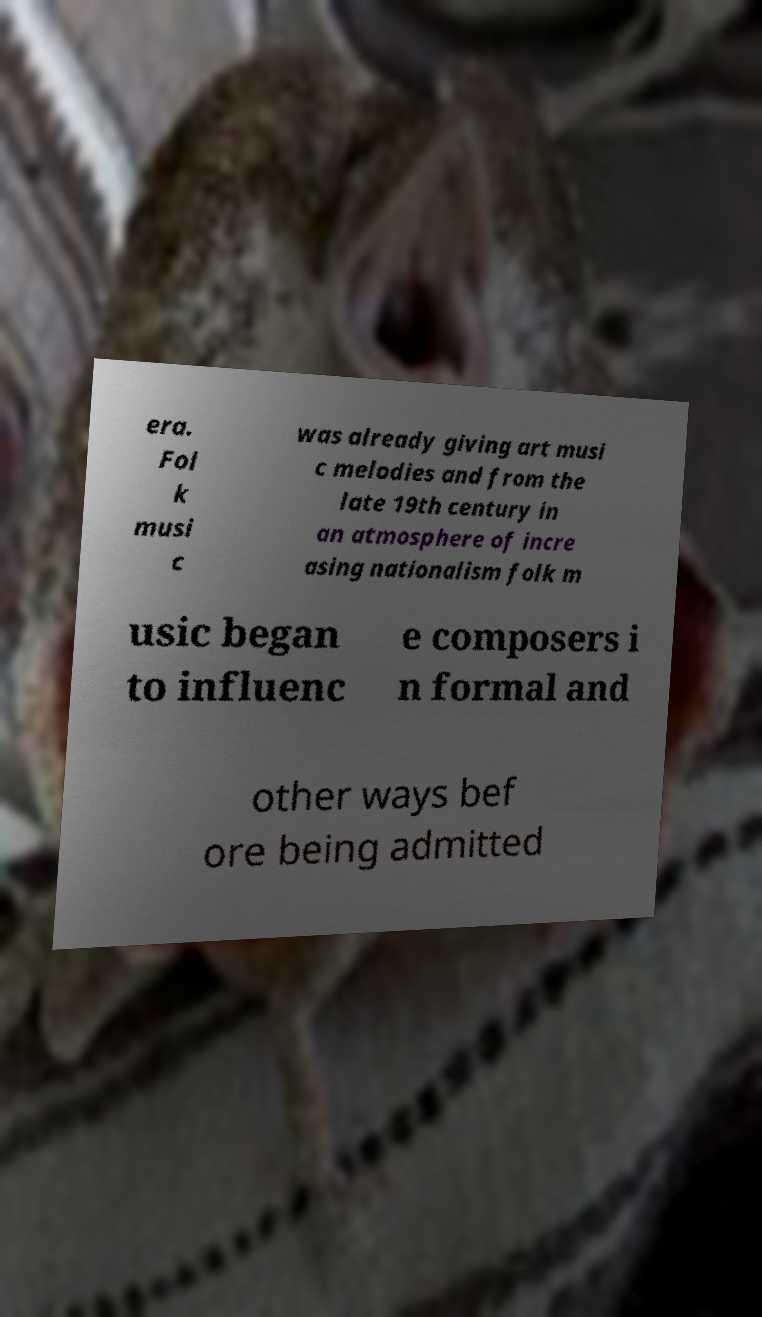Could you extract and type out the text from this image? era. Fol k musi c was already giving art musi c melodies and from the late 19th century in an atmosphere of incre asing nationalism folk m usic began to influenc e composers i n formal and other ways bef ore being admitted 